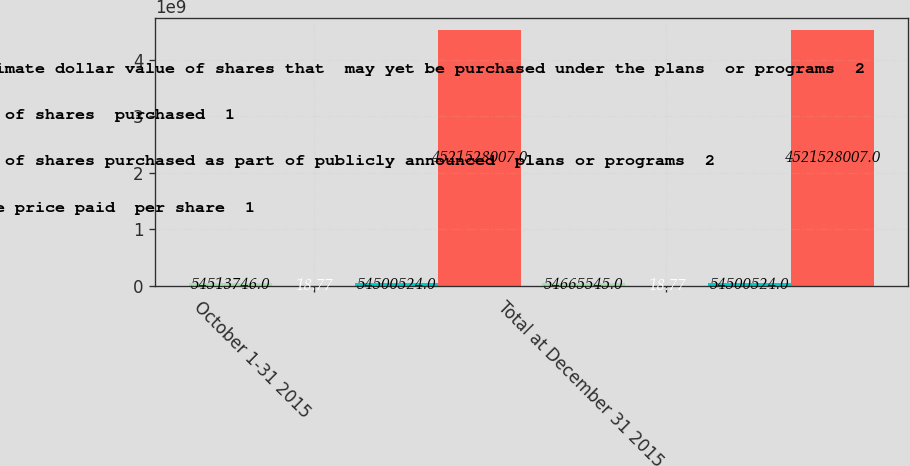<chart> <loc_0><loc_0><loc_500><loc_500><stacked_bar_chart><ecel><fcel>October 1-31 2015<fcel>Total at December 31 2015<nl><fcel>Approximate dollar value of shares that  may yet be purchased under the plans  or programs  2<fcel>5.45137e+07<fcel>5.46655e+07<nl><fcel>Number of shares  purchased  1<fcel>18.77<fcel>18.77<nl><fcel>Number of shares purchased as part of publicly announced  plans or programs  2<fcel>5.45005e+07<fcel>5.45005e+07<nl><fcel>Average price paid  per share  1<fcel>4.52153e+09<fcel>4.52153e+09<nl></chart> 